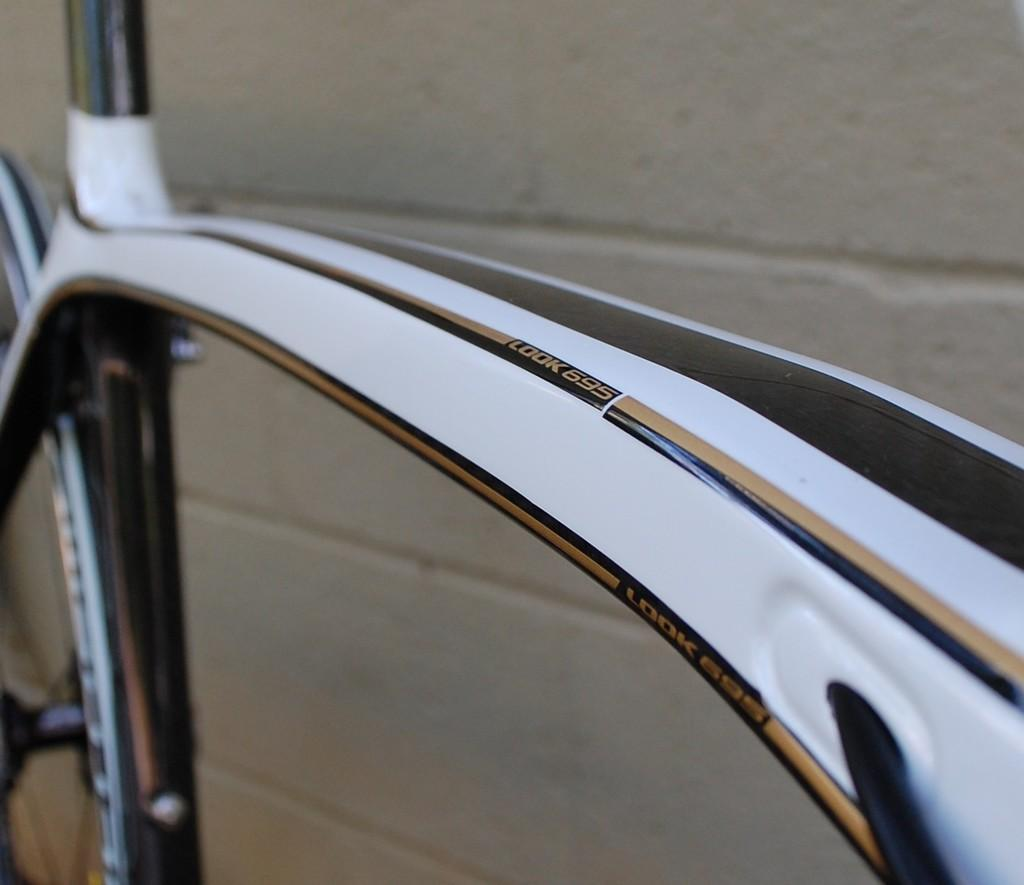What is the main object in the image? There is a bicycle in the image. Where is the bicycle located in relation to other objects or structures? The bicycle is near a wall. What type of education is being offered by the bicycle in the image? The bicycle in the image is not offering any education, as it is an inanimate object. 